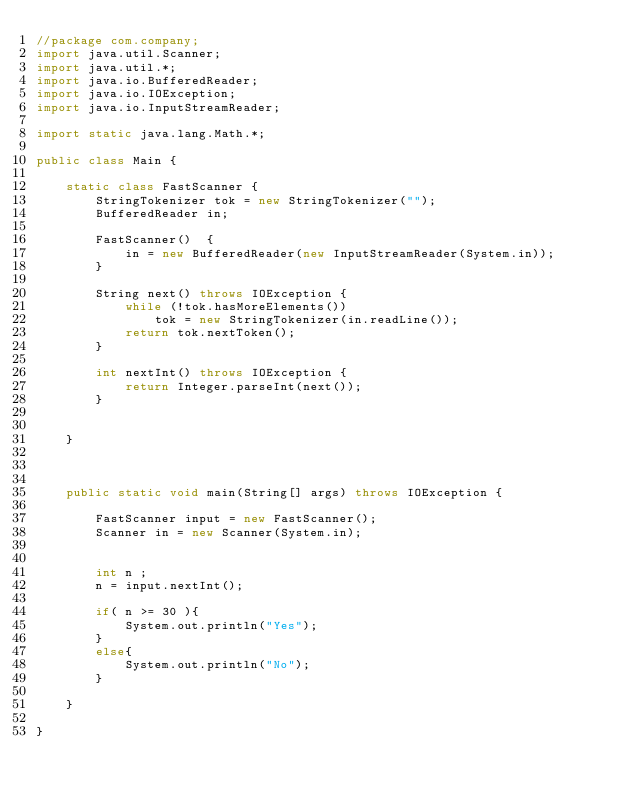Convert code to text. <code><loc_0><loc_0><loc_500><loc_500><_Java_>//package com.company;
import java.util.Scanner;
import java.util.*;
import java.io.BufferedReader;
import java.io.IOException;
import java.io.InputStreamReader;

import static java.lang.Math.*;

public class Main {

    static class FastScanner {
        StringTokenizer tok = new StringTokenizer("");
        BufferedReader in;

        FastScanner()  {
            in = new BufferedReader(new InputStreamReader(System.in));
        }

        String next() throws IOException {
            while (!tok.hasMoreElements())
                tok = new StringTokenizer(in.readLine());
            return tok.nextToken();
        }

        int nextInt() throws IOException {
            return Integer.parseInt(next());
        }


    }



    public static void main(String[] args) throws IOException {

        FastScanner input = new FastScanner();
        Scanner in = new Scanner(System.in);


        int n ;
        n = input.nextInt();

        if( n >= 30 ){
            System.out.println("Yes");
        }
        else{
            System.out.println("No");
        }

    }

}</code> 